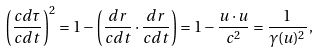Convert formula to latex. <formula><loc_0><loc_0><loc_500><loc_500>\left ( { \frac { c d \tau } { c d t } } \right ) ^ { 2 } = 1 - \left ( { \frac { d r } { c d t } } \cdot { \frac { d r } { c d t } } \right ) = 1 - { \frac { u \cdot u } { c ^ { 2 } } } = { \frac { 1 } { \gamma ( u ) ^ { 2 } } } \, ,</formula> 